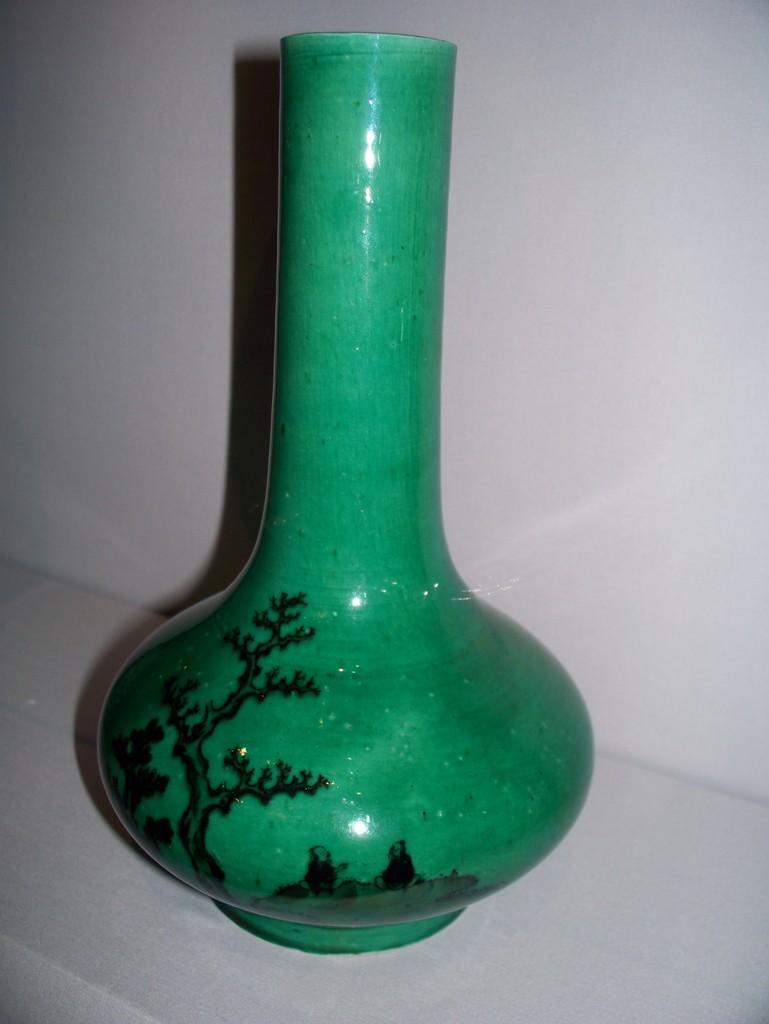Describe this image in one or two sentences. In this picture we can see design on green vase on the platform. In the background of the image we can see wall. 